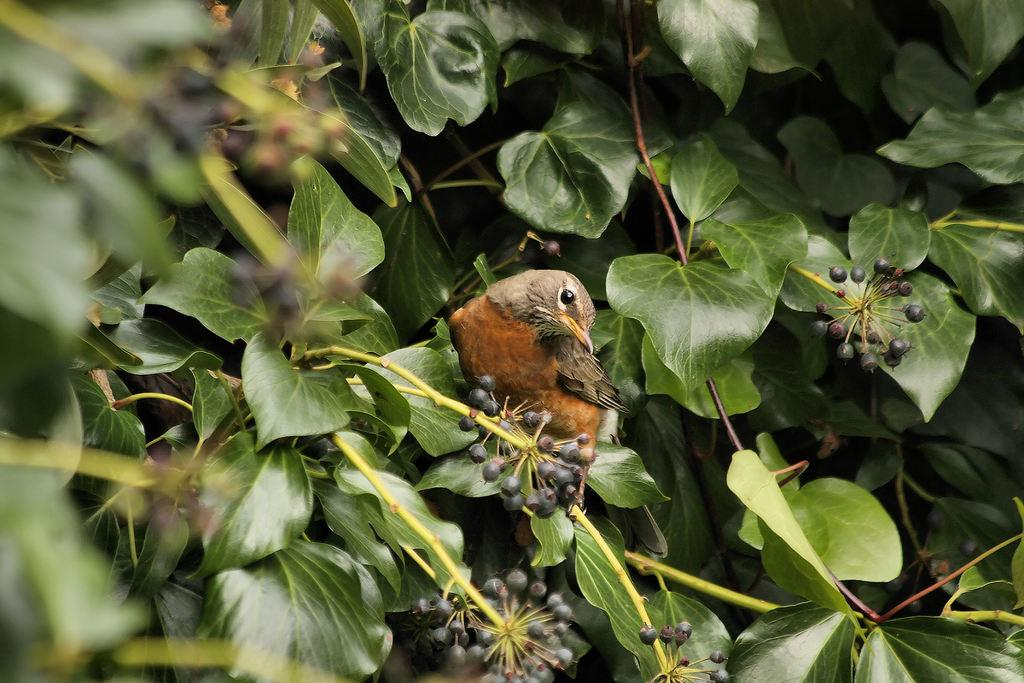What type of animal can be seen in the picture? There is a bird in the picture. What can be seen in the background of the picture? Leaves are visible in the picture. What else can be seen in the picture besides the bird? There are stems and fruits visible in the picture. What position does the match hold in the picture? There is no match present in the picture. How many fruits are visible in the bird's stomach in the picture? The picture does not show the bird's stomach, and there is no indication of the number of fruits inside it. 